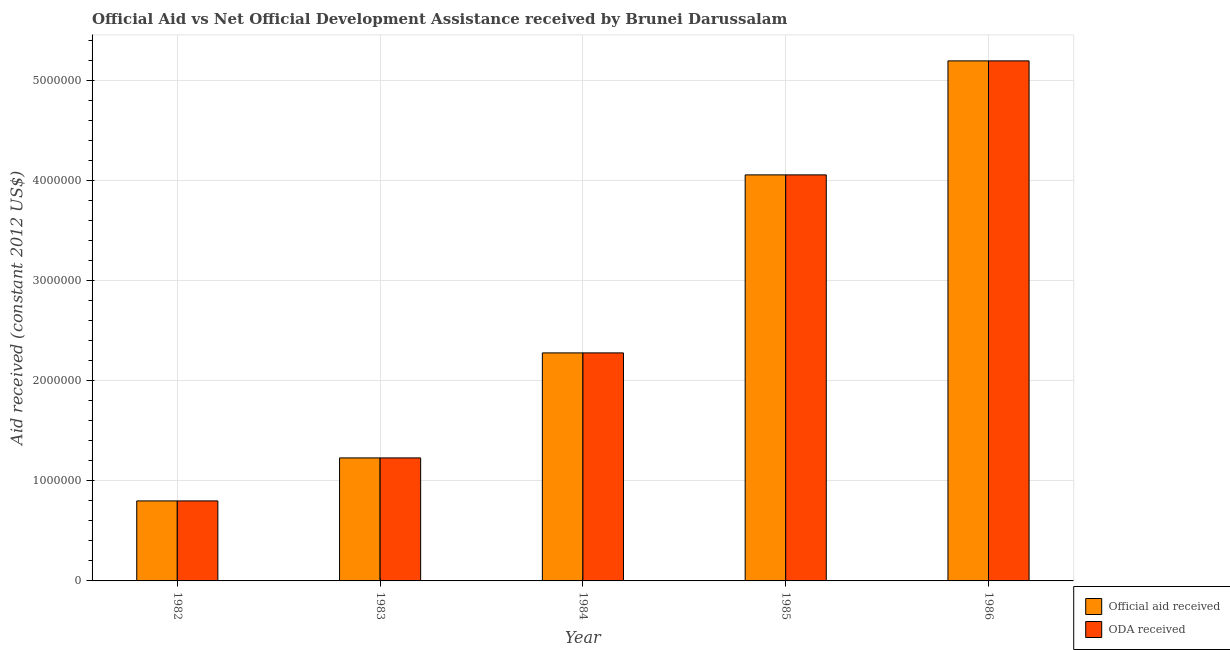How many bars are there on the 4th tick from the left?
Ensure brevity in your answer.  2. In how many cases, is the number of bars for a given year not equal to the number of legend labels?
Keep it short and to the point. 0. What is the oda received in 1982?
Keep it short and to the point. 8.00e+05. Across all years, what is the maximum official aid received?
Keep it short and to the point. 5.20e+06. Across all years, what is the minimum official aid received?
Provide a short and direct response. 8.00e+05. In which year was the oda received maximum?
Keep it short and to the point. 1986. In which year was the oda received minimum?
Ensure brevity in your answer.  1982. What is the total official aid received in the graph?
Provide a short and direct response. 1.36e+07. What is the difference between the official aid received in 1982 and that in 1986?
Ensure brevity in your answer.  -4.40e+06. What is the difference between the oda received in 1984 and the official aid received in 1982?
Make the answer very short. 1.48e+06. What is the average official aid received per year?
Keep it short and to the point. 2.71e+06. In how many years, is the oda received greater than 5200000 US$?
Make the answer very short. 0. What is the ratio of the official aid received in 1983 to that in 1984?
Give a very brief answer. 0.54. Is the oda received in 1984 less than that in 1986?
Offer a very short reply. Yes. What is the difference between the highest and the second highest official aid received?
Offer a terse response. 1.14e+06. What is the difference between the highest and the lowest official aid received?
Your response must be concise. 4.40e+06. In how many years, is the official aid received greater than the average official aid received taken over all years?
Your answer should be compact. 2. Is the sum of the official aid received in 1983 and 1986 greater than the maximum oda received across all years?
Make the answer very short. Yes. What does the 1st bar from the left in 1982 represents?
Ensure brevity in your answer.  Official aid received. What does the 2nd bar from the right in 1985 represents?
Keep it short and to the point. Official aid received. Are all the bars in the graph horizontal?
Provide a short and direct response. No. Does the graph contain any zero values?
Ensure brevity in your answer.  No. What is the title of the graph?
Offer a terse response. Official Aid vs Net Official Development Assistance received by Brunei Darussalam . Does "Banks" appear as one of the legend labels in the graph?
Offer a terse response. No. What is the label or title of the Y-axis?
Your response must be concise. Aid received (constant 2012 US$). What is the Aid received (constant 2012 US$) of Official aid received in 1982?
Make the answer very short. 8.00e+05. What is the Aid received (constant 2012 US$) of ODA received in 1982?
Your response must be concise. 8.00e+05. What is the Aid received (constant 2012 US$) of Official aid received in 1983?
Make the answer very short. 1.23e+06. What is the Aid received (constant 2012 US$) of ODA received in 1983?
Make the answer very short. 1.23e+06. What is the Aid received (constant 2012 US$) of Official aid received in 1984?
Your answer should be very brief. 2.28e+06. What is the Aid received (constant 2012 US$) in ODA received in 1984?
Your answer should be compact. 2.28e+06. What is the Aid received (constant 2012 US$) of Official aid received in 1985?
Offer a terse response. 4.06e+06. What is the Aid received (constant 2012 US$) in ODA received in 1985?
Ensure brevity in your answer.  4.06e+06. What is the Aid received (constant 2012 US$) in Official aid received in 1986?
Ensure brevity in your answer.  5.20e+06. What is the Aid received (constant 2012 US$) in ODA received in 1986?
Your answer should be very brief. 5.20e+06. Across all years, what is the maximum Aid received (constant 2012 US$) in Official aid received?
Your answer should be very brief. 5.20e+06. Across all years, what is the maximum Aid received (constant 2012 US$) of ODA received?
Make the answer very short. 5.20e+06. Across all years, what is the minimum Aid received (constant 2012 US$) in Official aid received?
Keep it short and to the point. 8.00e+05. Across all years, what is the minimum Aid received (constant 2012 US$) of ODA received?
Offer a very short reply. 8.00e+05. What is the total Aid received (constant 2012 US$) in Official aid received in the graph?
Keep it short and to the point. 1.36e+07. What is the total Aid received (constant 2012 US$) of ODA received in the graph?
Provide a succinct answer. 1.36e+07. What is the difference between the Aid received (constant 2012 US$) in Official aid received in 1982 and that in 1983?
Provide a succinct answer. -4.30e+05. What is the difference between the Aid received (constant 2012 US$) in ODA received in 1982 and that in 1983?
Keep it short and to the point. -4.30e+05. What is the difference between the Aid received (constant 2012 US$) in Official aid received in 1982 and that in 1984?
Provide a short and direct response. -1.48e+06. What is the difference between the Aid received (constant 2012 US$) in ODA received in 1982 and that in 1984?
Your answer should be compact. -1.48e+06. What is the difference between the Aid received (constant 2012 US$) of Official aid received in 1982 and that in 1985?
Give a very brief answer. -3.26e+06. What is the difference between the Aid received (constant 2012 US$) of ODA received in 1982 and that in 1985?
Your answer should be compact. -3.26e+06. What is the difference between the Aid received (constant 2012 US$) of Official aid received in 1982 and that in 1986?
Offer a terse response. -4.40e+06. What is the difference between the Aid received (constant 2012 US$) of ODA received in 1982 and that in 1986?
Offer a very short reply. -4.40e+06. What is the difference between the Aid received (constant 2012 US$) in Official aid received in 1983 and that in 1984?
Offer a very short reply. -1.05e+06. What is the difference between the Aid received (constant 2012 US$) in ODA received in 1983 and that in 1984?
Make the answer very short. -1.05e+06. What is the difference between the Aid received (constant 2012 US$) in Official aid received in 1983 and that in 1985?
Offer a terse response. -2.83e+06. What is the difference between the Aid received (constant 2012 US$) of ODA received in 1983 and that in 1985?
Your answer should be compact. -2.83e+06. What is the difference between the Aid received (constant 2012 US$) of Official aid received in 1983 and that in 1986?
Offer a very short reply. -3.97e+06. What is the difference between the Aid received (constant 2012 US$) of ODA received in 1983 and that in 1986?
Ensure brevity in your answer.  -3.97e+06. What is the difference between the Aid received (constant 2012 US$) in Official aid received in 1984 and that in 1985?
Your answer should be very brief. -1.78e+06. What is the difference between the Aid received (constant 2012 US$) in ODA received in 1984 and that in 1985?
Offer a terse response. -1.78e+06. What is the difference between the Aid received (constant 2012 US$) of Official aid received in 1984 and that in 1986?
Your answer should be compact. -2.92e+06. What is the difference between the Aid received (constant 2012 US$) in ODA received in 1984 and that in 1986?
Offer a terse response. -2.92e+06. What is the difference between the Aid received (constant 2012 US$) in Official aid received in 1985 and that in 1986?
Your answer should be compact. -1.14e+06. What is the difference between the Aid received (constant 2012 US$) in ODA received in 1985 and that in 1986?
Provide a short and direct response. -1.14e+06. What is the difference between the Aid received (constant 2012 US$) in Official aid received in 1982 and the Aid received (constant 2012 US$) in ODA received in 1983?
Your answer should be compact. -4.30e+05. What is the difference between the Aid received (constant 2012 US$) in Official aid received in 1982 and the Aid received (constant 2012 US$) in ODA received in 1984?
Offer a very short reply. -1.48e+06. What is the difference between the Aid received (constant 2012 US$) in Official aid received in 1982 and the Aid received (constant 2012 US$) in ODA received in 1985?
Give a very brief answer. -3.26e+06. What is the difference between the Aid received (constant 2012 US$) in Official aid received in 1982 and the Aid received (constant 2012 US$) in ODA received in 1986?
Keep it short and to the point. -4.40e+06. What is the difference between the Aid received (constant 2012 US$) of Official aid received in 1983 and the Aid received (constant 2012 US$) of ODA received in 1984?
Your response must be concise. -1.05e+06. What is the difference between the Aid received (constant 2012 US$) of Official aid received in 1983 and the Aid received (constant 2012 US$) of ODA received in 1985?
Your answer should be very brief. -2.83e+06. What is the difference between the Aid received (constant 2012 US$) in Official aid received in 1983 and the Aid received (constant 2012 US$) in ODA received in 1986?
Your answer should be very brief. -3.97e+06. What is the difference between the Aid received (constant 2012 US$) of Official aid received in 1984 and the Aid received (constant 2012 US$) of ODA received in 1985?
Your answer should be compact. -1.78e+06. What is the difference between the Aid received (constant 2012 US$) of Official aid received in 1984 and the Aid received (constant 2012 US$) of ODA received in 1986?
Provide a succinct answer. -2.92e+06. What is the difference between the Aid received (constant 2012 US$) in Official aid received in 1985 and the Aid received (constant 2012 US$) in ODA received in 1986?
Your answer should be very brief. -1.14e+06. What is the average Aid received (constant 2012 US$) of Official aid received per year?
Offer a terse response. 2.71e+06. What is the average Aid received (constant 2012 US$) in ODA received per year?
Offer a terse response. 2.71e+06. In the year 1985, what is the difference between the Aid received (constant 2012 US$) in Official aid received and Aid received (constant 2012 US$) in ODA received?
Keep it short and to the point. 0. What is the ratio of the Aid received (constant 2012 US$) in Official aid received in 1982 to that in 1983?
Provide a short and direct response. 0.65. What is the ratio of the Aid received (constant 2012 US$) of ODA received in 1982 to that in 1983?
Ensure brevity in your answer.  0.65. What is the ratio of the Aid received (constant 2012 US$) of Official aid received in 1982 to that in 1984?
Your answer should be very brief. 0.35. What is the ratio of the Aid received (constant 2012 US$) in ODA received in 1982 to that in 1984?
Provide a short and direct response. 0.35. What is the ratio of the Aid received (constant 2012 US$) of Official aid received in 1982 to that in 1985?
Provide a short and direct response. 0.2. What is the ratio of the Aid received (constant 2012 US$) in ODA received in 1982 to that in 1985?
Your response must be concise. 0.2. What is the ratio of the Aid received (constant 2012 US$) in Official aid received in 1982 to that in 1986?
Provide a short and direct response. 0.15. What is the ratio of the Aid received (constant 2012 US$) in ODA received in 1982 to that in 1986?
Your response must be concise. 0.15. What is the ratio of the Aid received (constant 2012 US$) in Official aid received in 1983 to that in 1984?
Provide a succinct answer. 0.54. What is the ratio of the Aid received (constant 2012 US$) of ODA received in 1983 to that in 1984?
Make the answer very short. 0.54. What is the ratio of the Aid received (constant 2012 US$) in Official aid received in 1983 to that in 1985?
Keep it short and to the point. 0.3. What is the ratio of the Aid received (constant 2012 US$) in ODA received in 1983 to that in 1985?
Make the answer very short. 0.3. What is the ratio of the Aid received (constant 2012 US$) of Official aid received in 1983 to that in 1986?
Keep it short and to the point. 0.24. What is the ratio of the Aid received (constant 2012 US$) of ODA received in 1983 to that in 1986?
Offer a very short reply. 0.24. What is the ratio of the Aid received (constant 2012 US$) of Official aid received in 1984 to that in 1985?
Your answer should be compact. 0.56. What is the ratio of the Aid received (constant 2012 US$) in ODA received in 1984 to that in 1985?
Offer a very short reply. 0.56. What is the ratio of the Aid received (constant 2012 US$) in Official aid received in 1984 to that in 1986?
Your answer should be compact. 0.44. What is the ratio of the Aid received (constant 2012 US$) of ODA received in 1984 to that in 1986?
Your answer should be compact. 0.44. What is the ratio of the Aid received (constant 2012 US$) of Official aid received in 1985 to that in 1986?
Ensure brevity in your answer.  0.78. What is the ratio of the Aid received (constant 2012 US$) in ODA received in 1985 to that in 1986?
Give a very brief answer. 0.78. What is the difference between the highest and the second highest Aid received (constant 2012 US$) in Official aid received?
Your response must be concise. 1.14e+06. What is the difference between the highest and the second highest Aid received (constant 2012 US$) of ODA received?
Make the answer very short. 1.14e+06. What is the difference between the highest and the lowest Aid received (constant 2012 US$) of Official aid received?
Your answer should be compact. 4.40e+06. What is the difference between the highest and the lowest Aid received (constant 2012 US$) of ODA received?
Provide a succinct answer. 4.40e+06. 